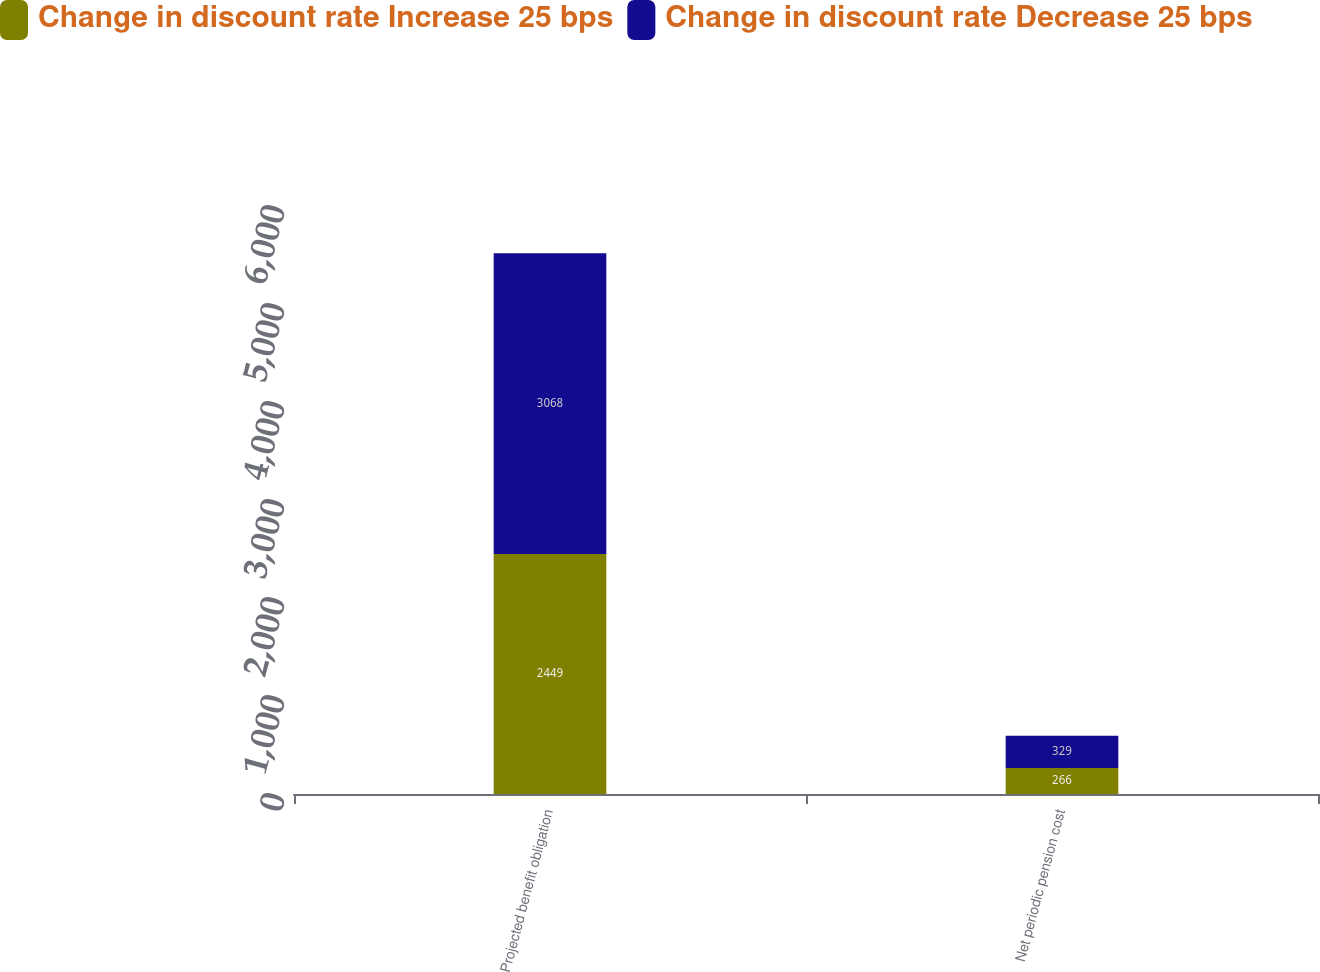<chart> <loc_0><loc_0><loc_500><loc_500><stacked_bar_chart><ecel><fcel>Projected benefit obligation<fcel>Net periodic pension cost<nl><fcel>Change in discount rate Increase 25 bps<fcel>2449<fcel>266<nl><fcel>Change in discount rate Decrease 25 bps<fcel>3068<fcel>329<nl></chart> 